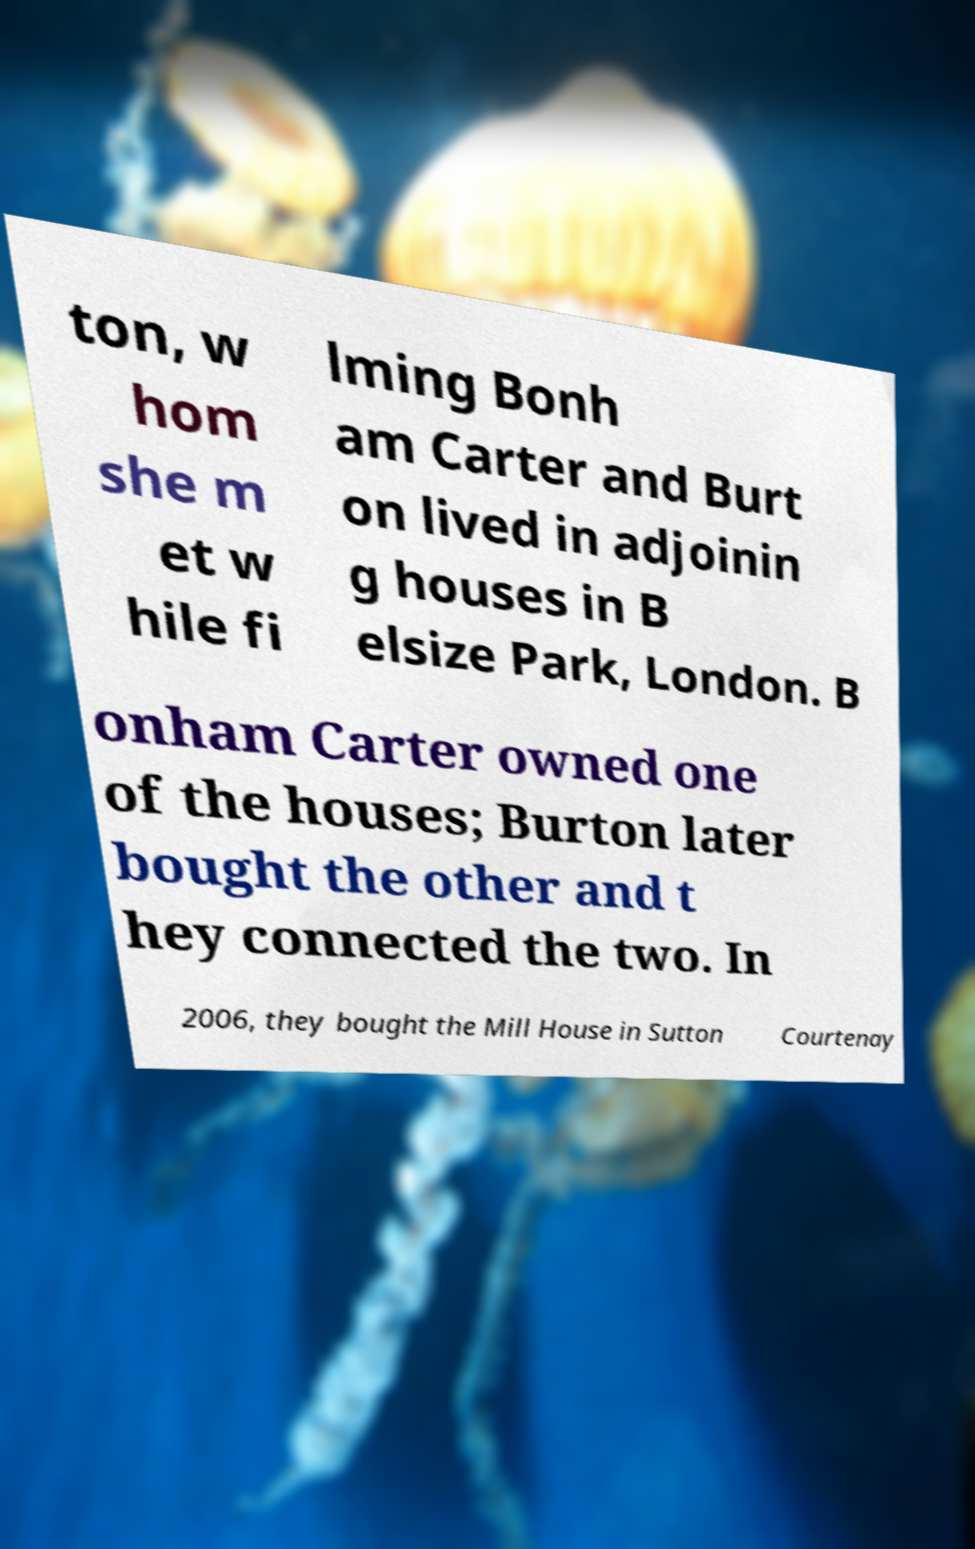There's text embedded in this image that I need extracted. Can you transcribe it verbatim? ton, w hom she m et w hile fi lming Bonh am Carter and Burt on lived in adjoinin g houses in B elsize Park, London. B onham Carter owned one of the houses; Burton later bought the other and t hey connected the two. In 2006, they bought the Mill House in Sutton Courtenay 